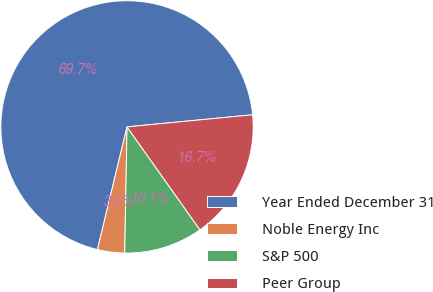Convert chart to OTSL. <chart><loc_0><loc_0><loc_500><loc_500><pie_chart><fcel>Year Ended December 31<fcel>Noble Energy Inc<fcel>S&P 500<fcel>Peer Group<nl><fcel>69.7%<fcel>3.48%<fcel>10.1%<fcel>16.72%<nl></chart> 